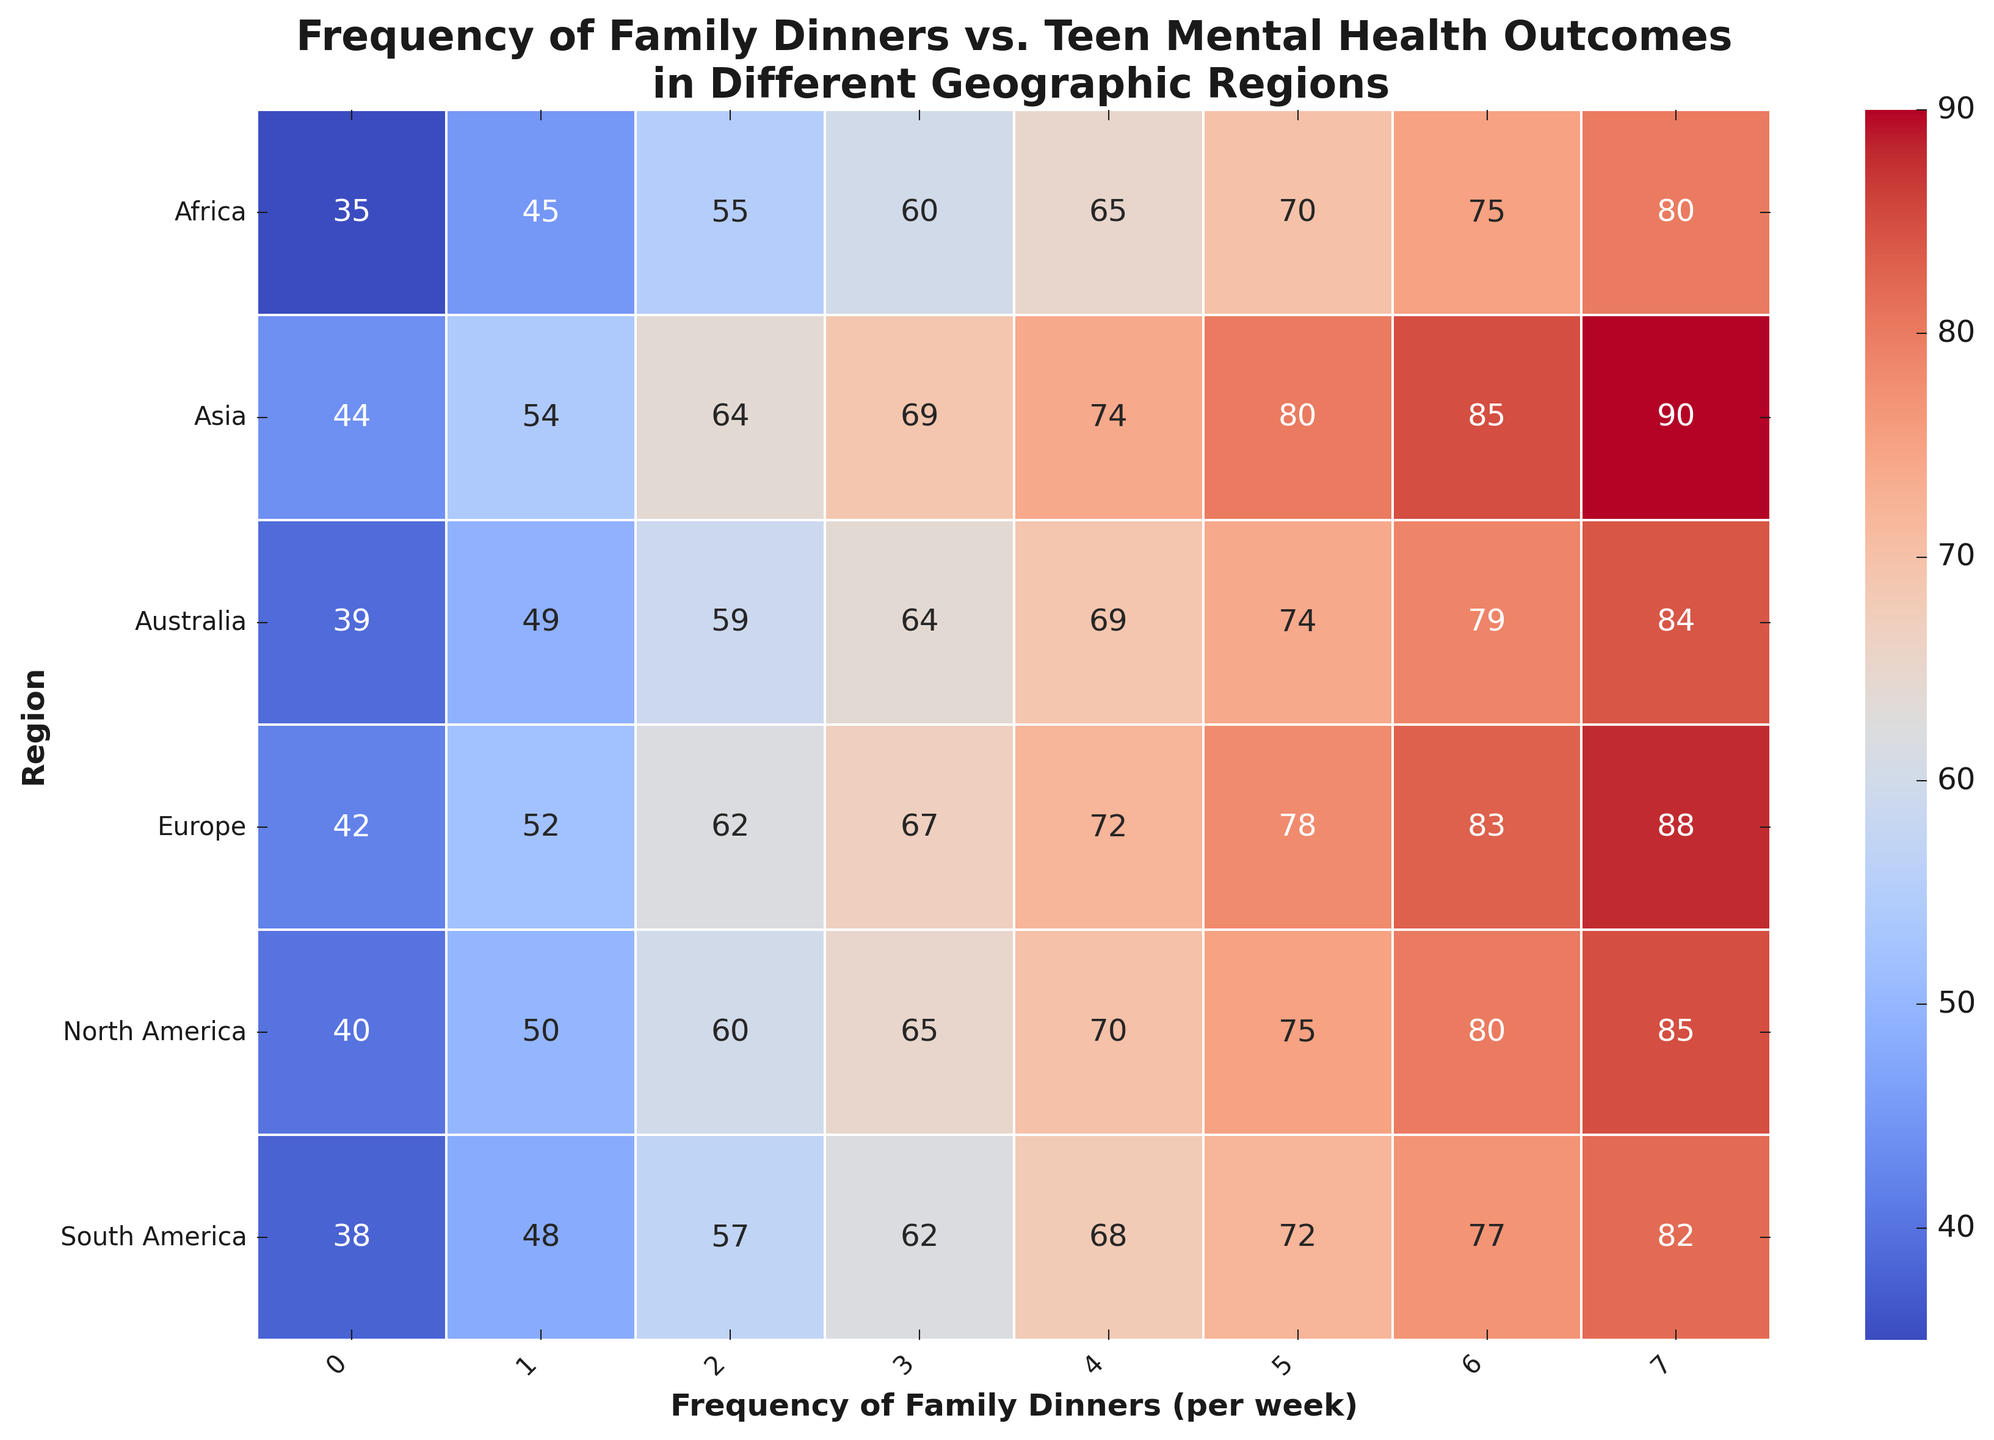What trend can be observed regarding the positive mental health outcomes as the frequency of family dinners decreases across all regions? As the frequency of family dinners decreases (from 7 to 0 per week), the positive mental health outcomes (%) also decrease in all regions. This trend is consistent, showing an inverse relationship.
Answer: Positive mental health outcomes decrease as family dinner frequency decreases Which region shows the highest positive mental health outcomes with 7 family dinners per week? By observing the heatmap, Asia shows the highest positive mental health outcomes (90%) with 7 family dinners per week.
Answer: Asia Which region has the lowest positive mental health outcomes with 0 family dinners per week? From the heatmap, Africa has the lowest positive mental health outcomes (35%) with 0 family dinners per week.
Answer: Africa Compare the positive mental health outcomes for North America and Europe with 5 family dinners per week. Which region has a higher outcome? According to the heatmap, North America has a positive mental health outcome of 75%, while Europe has 78% with 5 family dinners per week. Europe has a higher outcome.
Answer: Europe Calculate the average positive mental health outcomes across all regions with 3 family dinners per week. Add the positive mental health outcomes for each region with 3 family dinners per week: 65 (North America) + 67 (Europe) + 69 (Asia) + 60 (Africa) + 62 (South America) + 64 (Australia) = 387. There are 6 regions, thus the average is 387/6 = 64.5.
Answer: 64.5 Which region exhibits the least variability in positive mental health outcomes across the different frequencies of family dinners? By visual inspection, Asia's positive mental health outcomes consistently range from 44% to 90%, showing less fluctuation compared to other regions, indicating the least variability.
Answer: Asia How does the positive mental health outcome with 2 family dinners per week compare between South America and Australia? According to the heatmap, South America has 57% and Australia has 59% positive mental health outcomes with 2 family dinners per week. Australia has slightly higher outcomes.
Answer: Australia What is the range of positive mental health outcomes for Africa as the frequency of family dinners changes from 0 to 7? The range is calculated as the difference between the maximum and minimum values: 80% (7 dinners) - 35% (0 dinners) = 45%.
Answer: 45% Which region has the narrowest color gradient, indicating less fluctuation in outcomes, and what might this suggest about family dinners' impact in that region? Asia shows the narrowest color gradient, suggesting a more consistent impact of family dinners on positive mental health outcomes, with less fluctuation in results.
Answer: Asia Compare the overall impact of family dinners on positive mental health outcomes between North America and Europe. Which region benefits more from frequent family dinners? By observing the positive mental health outcomes, Europe generally shows higher percentages compared to North America across most frequencies of family dinners, indicating it benefits more from frequent family dinners.
Answer: Europe 